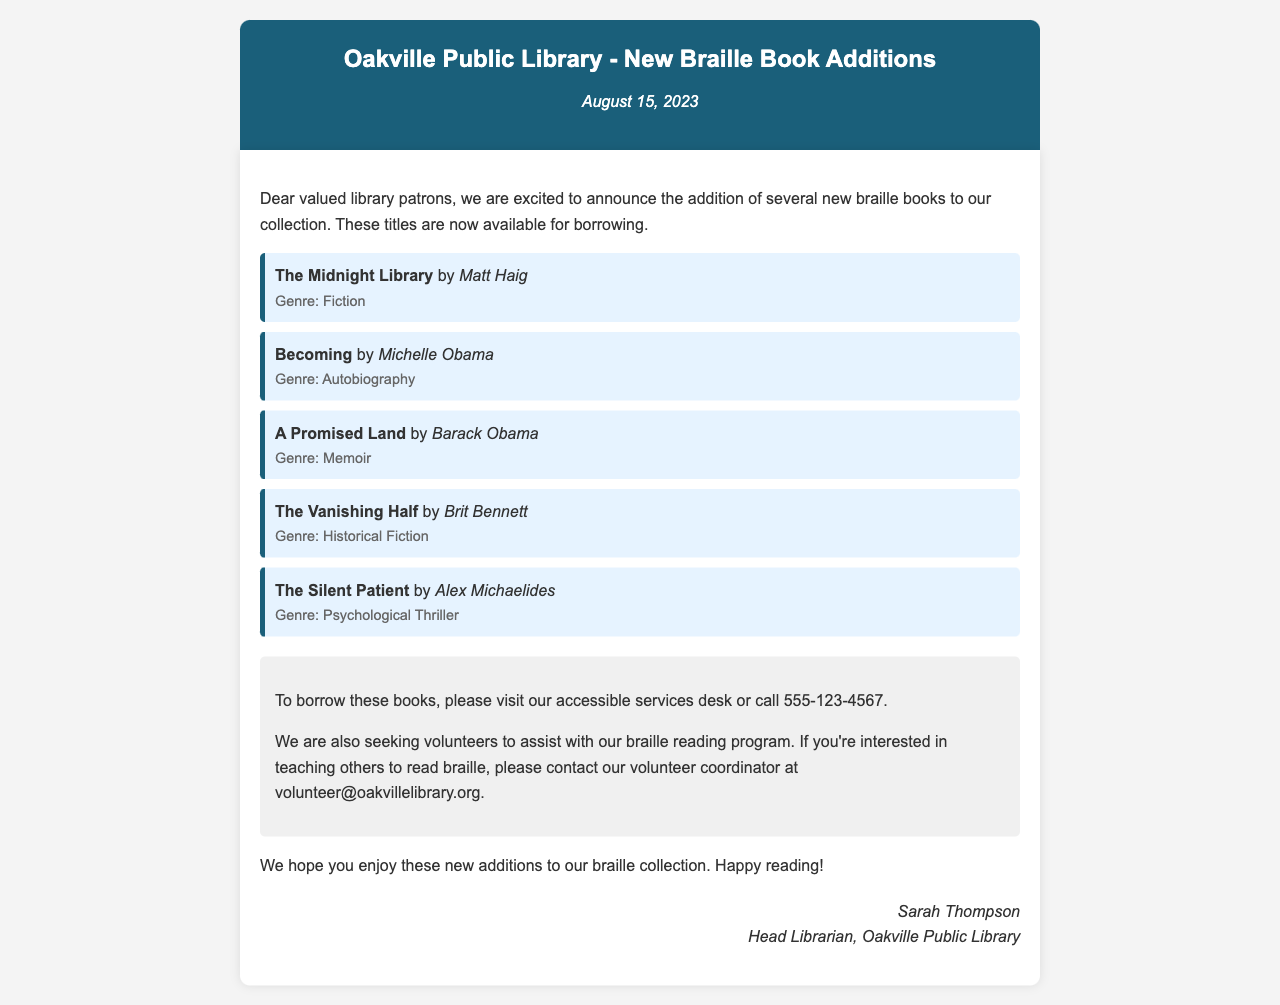What is the date of the announcement? The date of the announcement is stated at the top of the document.
Answer: August 15, 2023 Who is the author of "The Midnight Library"? This information can be found in the book list section.
Answer: Matt Haig What genre is "Becoming"? This genre is indicated next to the title in the list.
Answer: Autobiography Which book was written by Barack Obama? This question requires locating the title associated with the specified author.
Answer: A Promised Land How can patrons borrow the new braille books? The document provides specific instructions on how to borrow the books.
Answer: Visit the accessible services desk or call 555-123-4567 Who is the Head Librarian? The signature section at the end lists the Head Librarian's name.
Answer: Sarah Thompson What is the purpose of contacting the volunteer coordinator? This information is provided in the last part of the document in relation to volunteer efforts.
Answer: To assist with the braille reading program How many new braille books are mentioned? This requires counting the items in the book list section.
Answer: Five 